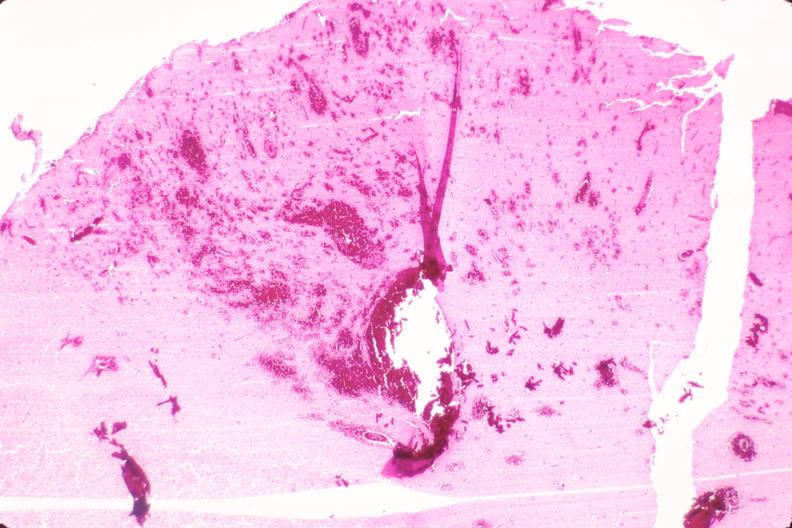does this image show brain, infarct and hemorrhage due to ruptured saccular aneurysm and thrombosis of right middle cerebral artery?
Answer the question using a single word or phrase. Yes 